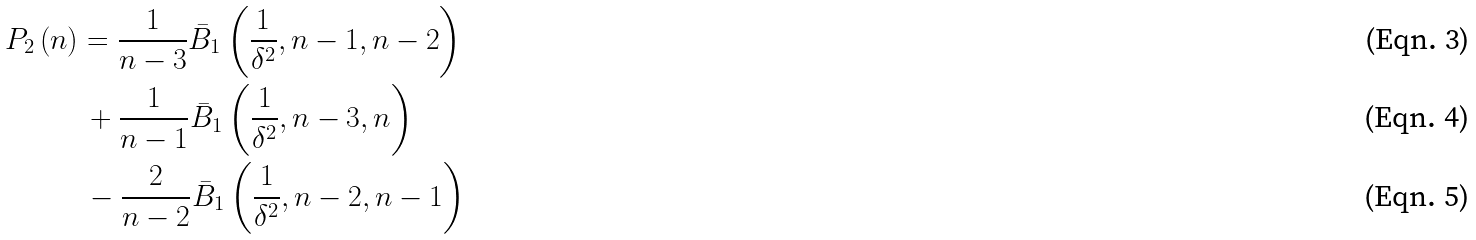Convert formula to latex. <formula><loc_0><loc_0><loc_500><loc_500>{ P _ { 2 } } \left ( n \right ) & = \frac { 1 } { n - 3 } { { \bar { B } } _ { 1 } } \left ( { \frac { 1 } { \delta ^ { 2 } } , n - 1 , n - 2 } \right ) \\ & \, + \frac { 1 } { n - 1 } { { \bar { B } } _ { 1 } } \left ( { \frac { 1 } { \delta ^ { 2 } } , n - 3 , n } \right ) \\ & \, - \frac { 2 } { n - 2 } { { \bar { B } } _ { 1 } } \left ( { \frac { 1 } { \delta ^ { 2 } } , n - 2 , n - 1 } \right )</formula> 